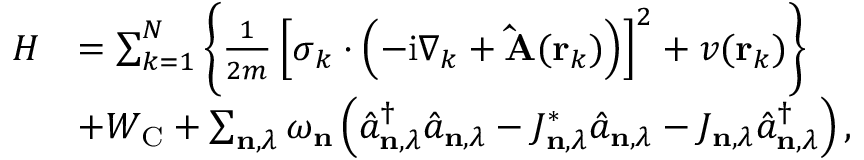Convert formula to latex. <formula><loc_0><loc_0><loc_500><loc_500>\begin{array} { r l } { H } & { = \sum _ { k = 1 } ^ { N } \left \{ \frac { 1 } { 2 m } \left [ \sigma _ { k } \cdot \left ( - i \nabla _ { k } + \hat { A } ( r _ { k } ) \right ) \right ] ^ { 2 } + v ( r _ { k } ) \right \} } \\ & { + W _ { C } + \sum _ { n , \lambda } \omega _ { n } \left ( \hat { a } _ { n , \lambda } ^ { \dagger } \hat { a } _ { n , \lambda } - J _ { n , \lambda } ^ { * } \hat { a } _ { n , \lambda } - J _ { n , \lambda } \hat { a } _ { n , \lambda } ^ { \dagger } \right ) , } \end{array}</formula> 